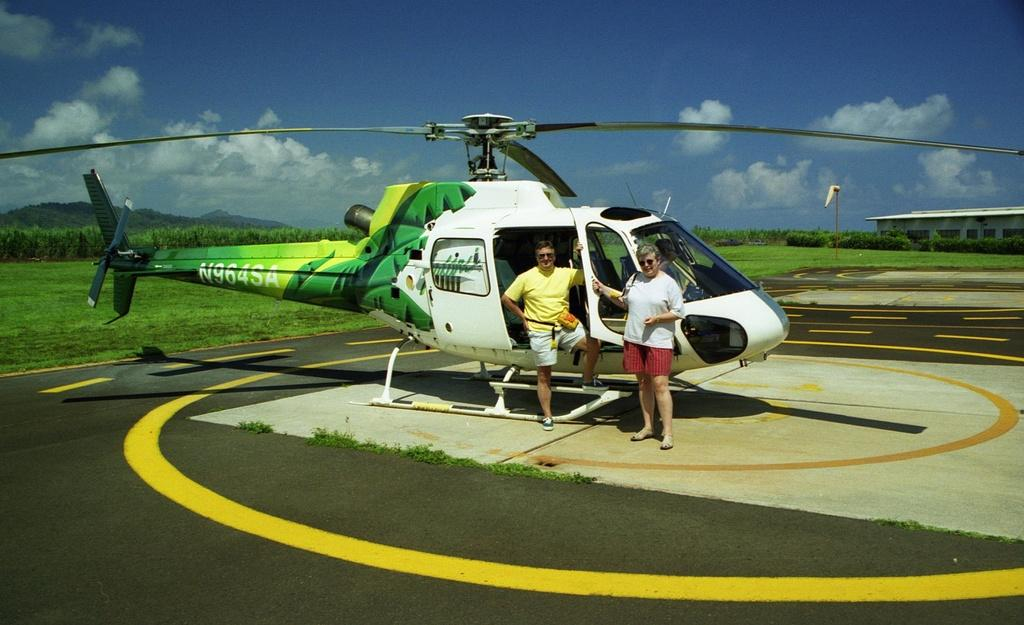How many people are in the image? There are two persons in the image. What is the unusual object on the road in the image? There is a helicopter on the road in the image. What type of vegetation can be seen in the image? Grass and plants are visible in the image. What structure can be seen in the image? There is a pole and a shed in the image. What is visible in the background of the image? The sky is visible in the background of the image, and clouds are present in the sky. What type of smoke can be seen coming from the thing in the image? There is no smoke or thing present in the image. 